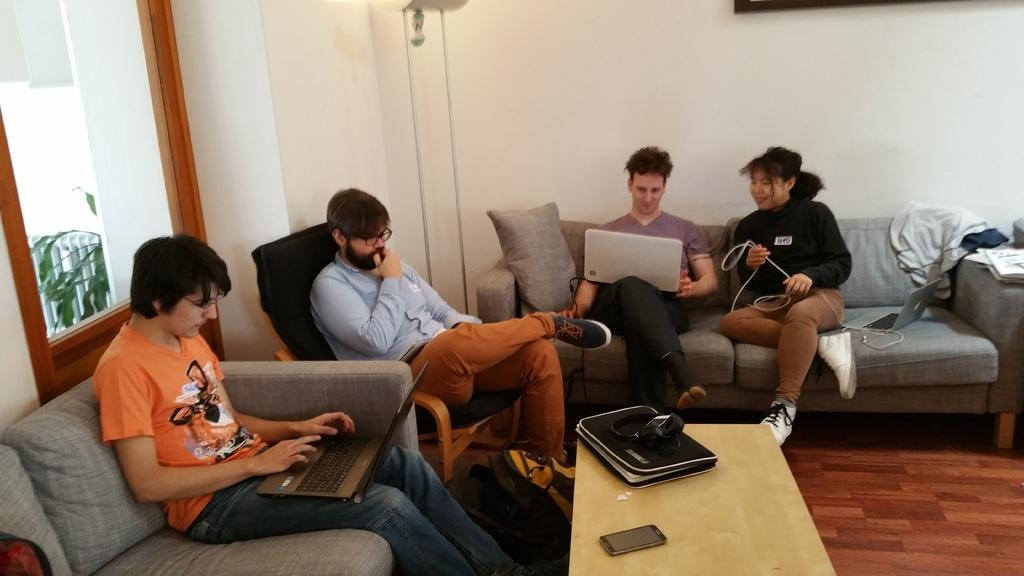What are the people in the image doing? There is a group of people sitting on a couch in the image. What can be seen on the table in the image? There is a file and a mobile phone on the table in the image. What is present in the background of the image? There is a plant and a window in the background of the image. Where is the kettle located in the image? There is no kettle present in the image. What type of cork is used to hold the plant in the image? There is no cork present in the image, as the plant is not shown to be held by any specific material. 